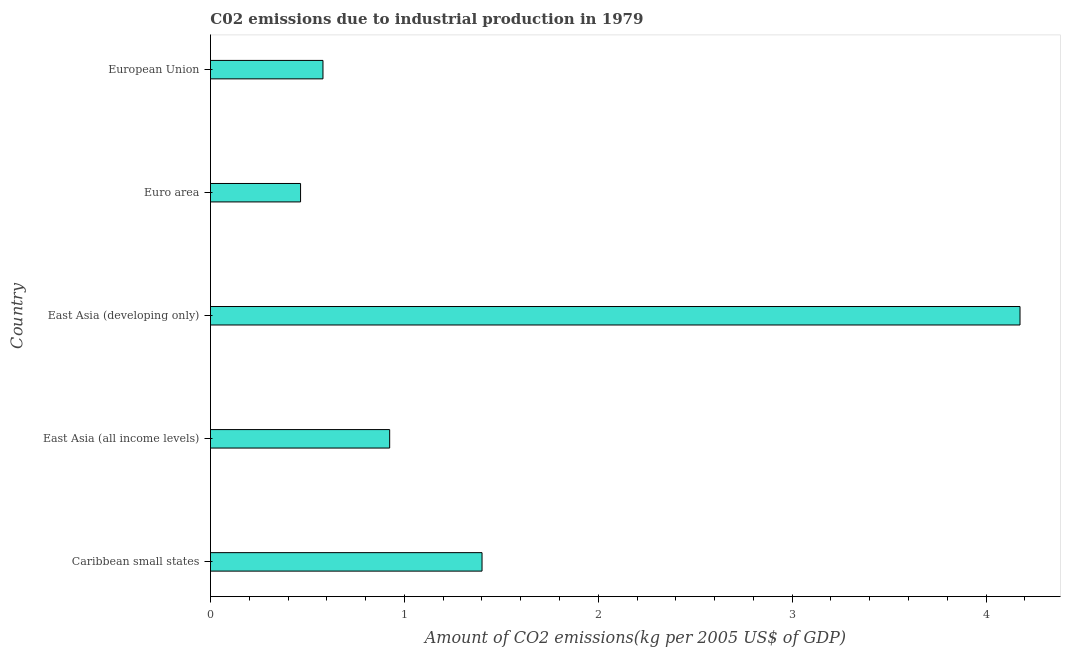Does the graph contain any zero values?
Provide a succinct answer. No. What is the title of the graph?
Offer a terse response. C02 emissions due to industrial production in 1979. What is the label or title of the X-axis?
Offer a terse response. Amount of CO2 emissions(kg per 2005 US$ of GDP). What is the amount of co2 emissions in Euro area?
Your answer should be compact. 0.46. Across all countries, what is the maximum amount of co2 emissions?
Make the answer very short. 4.18. Across all countries, what is the minimum amount of co2 emissions?
Offer a very short reply. 0.46. In which country was the amount of co2 emissions maximum?
Make the answer very short. East Asia (developing only). What is the sum of the amount of co2 emissions?
Your answer should be very brief. 7.54. What is the difference between the amount of co2 emissions in East Asia (developing only) and European Union?
Offer a terse response. 3.6. What is the average amount of co2 emissions per country?
Make the answer very short. 1.51. What is the median amount of co2 emissions?
Make the answer very short. 0.92. What is the ratio of the amount of co2 emissions in East Asia (developing only) to that in European Union?
Ensure brevity in your answer.  7.2. Is the amount of co2 emissions in Caribbean small states less than that in East Asia (developing only)?
Keep it short and to the point. Yes. What is the difference between the highest and the second highest amount of co2 emissions?
Provide a short and direct response. 2.77. What is the difference between the highest and the lowest amount of co2 emissions?
Your response must be concise. 3.71. Are all the bars in the graph horizontal?
Provide a short and direct response. Yes. How many countries are there in the graph?
Offer a terse response. 5. What is the difference between two consecutive major ticks on the X-axis?
Keep it short and to the point. 1. Are the values on the major ticks of X-axis written in scientific E-notation?
Ensure brevity in your answer.  No. What is the Amount of CO2 emissions(kg per 2005 US$ of GDP) in Caribbean small states?
Offer a terse response. 1.4. What is the Amount of CO2 emissions(kg per 2005 US$ of GDP) in East Asia (all income levels)?
Your answer should be very brief. 0.92. What is the Amount of CO2 emissions(kg per 2005 US$ of GDP) of East Asia (developing only)?
Your response must be concise. 4.18. What is the Amount of CO2 emissions(kg per 2005 US$ of GDP) of Euro area?
Offer a terse response. 0.46. What is the Amount of CO2 emissions(kg per 2005 US$ of GDP) of European Union?
Your response must be concise. 0.58. What is the difference between the Amount of CO2 emissions(kg per 2005 US$ of GDP) in Caribbean small states and East Asia (all income levels)?
Ensure brevity in your answer.  0.48. What is the difference between the Amount of CO2 emissions(kg per 2005 US$ of GDP) in Caribbean small states and East Asia (developing only)?
Offer a terse response. -2.77. What is the difference between the Amount of CO2 emissions(kg per 2005 US$ of GDP) in Caribbean small states and Euro area?
Make the answer very short. 0.94. What is the difference between the Amount of CO2 emissions(kg per 2005 US$ of GDP) in Caribbean small states and European Union?
Give a very brief answer. 0.82. What is the difference between the Amount of CO2 emissions(kg per 2005 US$ of GDP) in East Asia (all income levels) and East Asia (developing only)?
Keep it short and to the point. -3.25. What is the difference between the Amount of CO2 emissions(kg per 2005 US$ of GDP) in East Asia (all income levels) and Euro area?
Provide a short and direct response. 0.46. What is the difference between the Amount of CO2 emissions(kg per 2005 US$ of GDP) in East Asia (all income levels) and European Union?
Offer a terse response. 0.34. What is the difference between the Amount of CO2 emissions(kg per 2005 US$ of GDP) in East Asia (developing only) and Euro area?
Provide a short and direct response. 3.71. What is the difference between the Amount of CO2 emissions(kg per 2005 US$ of GDP) in East Asia (developing only) and European Union?
Offer a terse response. 3.59. What is the difference between the Amount of CO2 emissions(kg per 2005 US$ of GDP) in Euro area and European Union?
Your answer should be very brief. -0.12. What is the ratio of the Amount of CO2 emissions(kg per 2005 US$ of GDP) in Caribbean small states to that in East Asia (all income levels)?
Keep it short and to the point. 1.51. What is the ratio of the Amount of CO2 emissions(kg per 2005 US$ of GDP) in Caribbean small states to that in East Asia (developing only)?
Your response must be concise. 0.34. What is the ratio of the Amount of CO2 emissions(kg per 2005 US$ of GDP) in Caribbean small states to that in Euro area?
Your response must be concise. 3.01. What is the ratio of the Amount of CO2 emissions(kg per 2005 US$ of GDP) in Caribbean small states to that in European Union?
Give a very brief answer. 2.41. What is the ratio of the Amount of CO2 emissions(kg per 2005 US$ of GDP) in East Asia (all income levels) to that in East Asia (developing only)?
Offer a terse response. 0.22. What is the ratio of the Amount of CO2 emissions(kg per 2005 US$ of GDP) in East Asia (all income levels) to that in Euro area?
Give a very brief answer. 1.99. What is the ratio of the Amount of CO2 emissions(kg per 2005 US$ of GDP) in East Asia (all income levels) to that in European Union?
Provide a short and direct response. 1.59. What is the ratio of the Amount of CO2 emissions(kg per 2005 US$ of GDP) in East Asia (developing only) to that in Euro area?
Ensure brevity in your answer.  8.99. What is the ratio of the Amount of CO2 emissions(kg per 2005 US$ of GDP) in East Asia (developing only) to that in European Union?
Provide a short and direct response. 7.2. What is the ratio of the Amount of CO2 emissions(kg per 2005 US$ of GDP) in Euro area to that in European Union?
Offer a terse response. 0.8. 